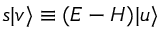<formula> <loc_0><loc_0><loc_500><loc_500>s | v \rangle \equiv ( E - H ) | u \rangle</formula> 